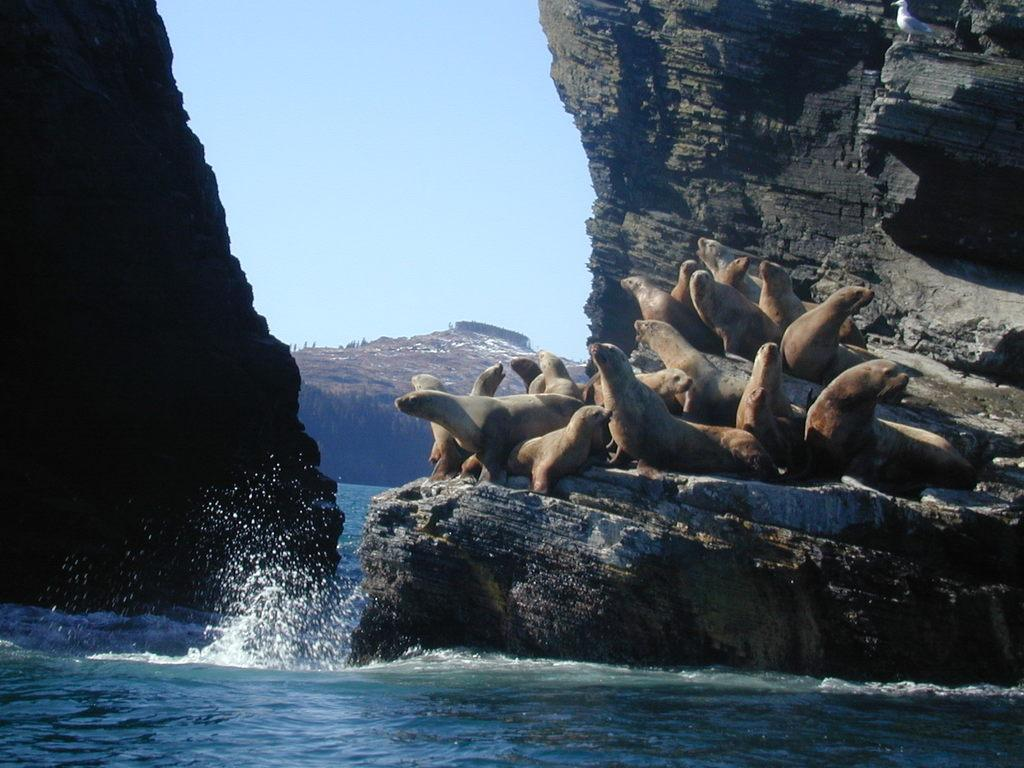What animals can be seen in the foreground of the image? There are sea lions on a rock in the foreground of the image. What is visible at the bottom of the image? Water is visible at the bottom of the image. What type of landscape can be seen in the background of the image? Rocks are present in the background of the image. What is visible in the sky in the background of the image? The sky is visible in the background of the image. Where is the bottle of water placed in the image? There is no bottle of water present in the image. What type of flame can be seen in the image? There is no flame present in the image. 